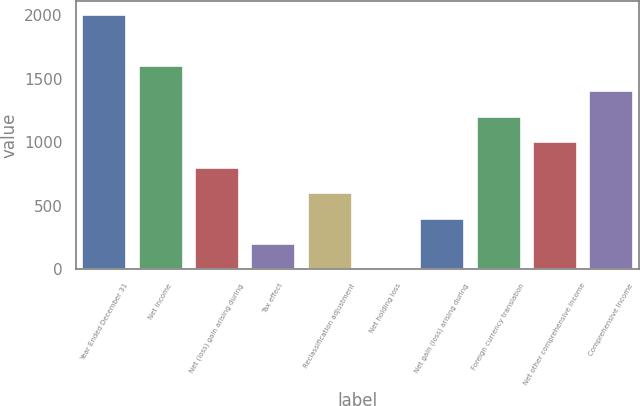Convert chart. <chart><loc_0><loc_0><loc_500><loc_500><bar_chart><fcel>Year Ended December 31<fcel>Net income<fcel>Net (loss) gain arising during<fcel>Tax effect<fcel>Reclassification adjustment<fcel>Net holding loss<fcel>Net gain (loss) arising during<fcel>Foreign currency translation<fcel>Net other comprehensive income<fcel>Comprehensive Income<nl><fcel>2015<fcel>1612.46<fcel>807.38<fcel>203.57<fcel>606.11<fcel>2.3<fcel>404.84<fcel>1209.92<fcel>1008.65<fcel>1411.19<nl></chart> 